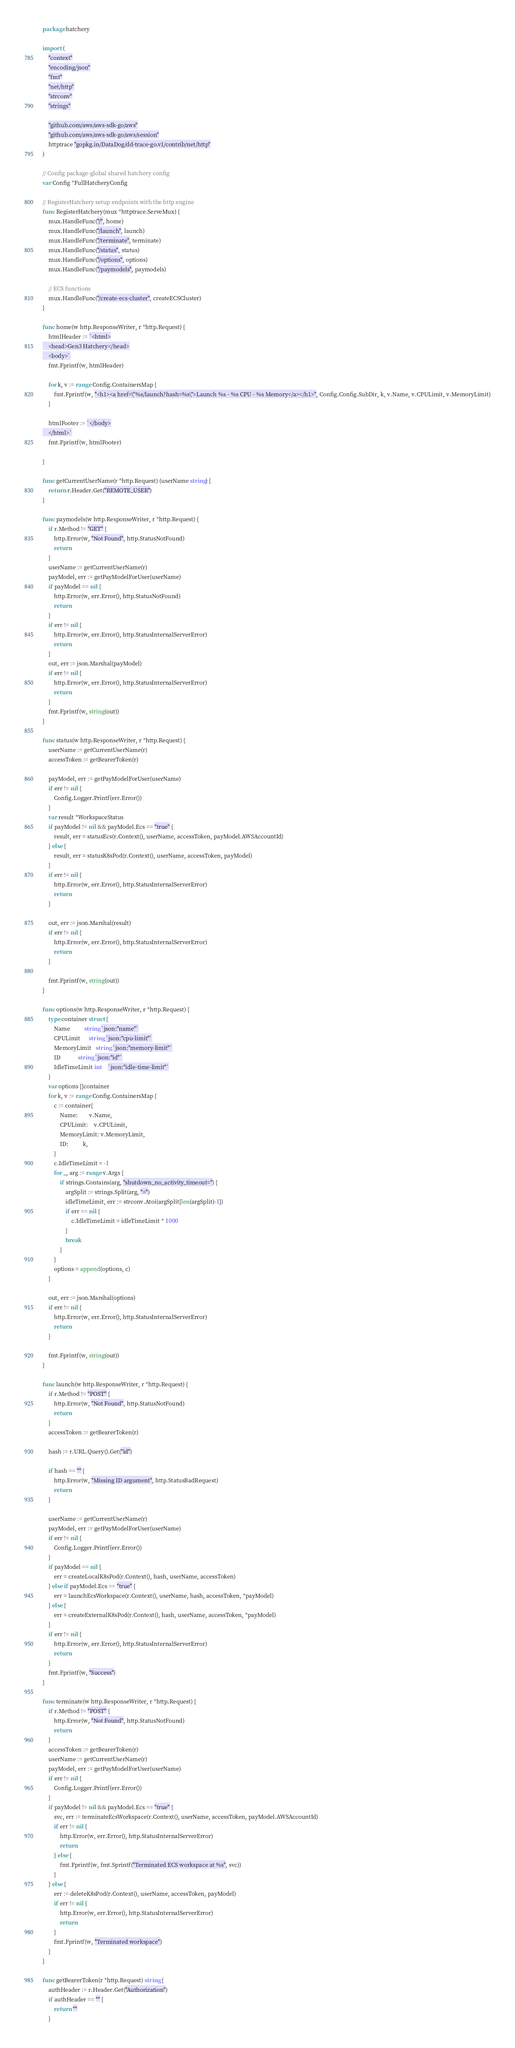<code> <loc_0><loc_0><loc_500><loc_500><_Go_>package hatchery

import (
	"context"
	"encoding/json"
	"fmt"
	"net/http"
	"strconv"
	"strings"

	"github.com/aws/aws-sdk-go/aws"
	"github.com/aws/aws-sdk-go/aws/session"
	httptrace "gopkg.in/DataDog/dd-trace-go.v1/contrib/net/http"
)

// Config package-global shared hatchery config
var Config *FullHatcheryConfig

// RegisterHatchery setup endpoints with the http engine
func RegisterHatchery(mux *httptrace.ServeMux) {
	mux.HandleFunc("/", home)
	mux.HandleFunc("/launch", launch)
	mux.HandleFunc("/terminate", terminate)
	mux.HandleFunc("/status", status)
	mux.HandleFunc("/options", options)
	mux.HandleFunc("/paymodels", paymodels)

	// ECS functions
	mux.HandleFunc("/create-ecs-cluster", createECSCluster)
}

func home(w http.ResponseWriter, r *http.Request) {
	htmlHeader := `<html>
	<head>Gen3 Hatchery</head>
	<body>`
	fmt.Fprintf(w, htmlHeader)

	for k, v := range Config.ContainersMap {
		fmt.Fprintf(w, "<h1><a href=\"%s/launch?hash=%s\">Launch %s - %s CPU - %s Memory</a></h1>", Config.Config.SubDir, k, v.Name, v.CPULimit, v.MemoryLimit)
	}

	htmlFooter := `</body>
	</html>`
	fmt.Fprintf(w, htmlFooter)

}

func getCurrentUserName(r *http.Request) (userName string) {
	return r.Header.Get("REMOTE_USER")
}

func paymodels(w http.ResponseWriter, r *http.Request) {
	if r.Method != "GET" {
		http.Error(w, "Not Found", http.StatusNotFound)
		return
	}
	userName := getCurrentUserName(r)
	payModel, err := getPayModelForUser(userName)
	if payModel == nil {
		http.Error(w, err.Error(), http.StatusNotFound)
		return
	}
	if err != nil {
		http.Error(w, err.Error(), http.StatusInternalServerError)
		return
	}
	out, err := json.Marshal(payModel)
	if err != nil {
		http.Error(w, err.Error(), http.StatusInternalServerError)
		return
	}
	fmt.Fprintf(w, string(out))
}

func status(w http.ResponseWriter, r *http.Request) {
	userName := getCurrentUserName(r)
	accessToken := getBearerToken(r)

	payModel, err := getPayModelForUser(userName)
	if err != nil {
		Config.Logger.Printf(err.Error())
	}
	var result *WorkspaceStatus
	if payModel != nil && payModel.Ecs == "true" {
		result, err = statusEcs(r.Context(), userName, accessToken, payModel.AWSAccountId)
	} else {
		result, err = statusK8sPod(r.Context(), userName, accessToken, payModel)
	}
	if err != nil {
		http.Error(w, err.Error(), http.StatusInternalServerError)
		return
	}

	out, err := json.Marshal(result)
	if err != nil {
		http.Error(w, err.Error(), http.StatusInternalServerError)
		return
	}

	fmt.Fprintf(w, string(out))
}

func options(w http.ResponseWriter, r *http.Request) {
	type container struct {
		Name          string `json:"name"`
		CPULimit      string `json:"cpu-limit"`
		MemoryLimit   string `json:"memory-limit"`
		ID            string `json:"id"`
		IdleTimeLimit int    `json:"idle-time-limit"`
	}
	var options []container
	for k, v := range Config.ContainersMap {
		c := container{
			Name:        v.Name,
			CPULimit:    v.CPULimit,
			MemoryLimit: v.MemoryLimit,
			ID:          k,
		}
		c.IdleTimeLimit = -1
		for _, arg := range v.Args {
			if strings.Contains(arg, "shutdown_no_activity_timeout=") {
				argSplit := strings.Split(arg, "=")
				idleTimeLimit, err := strconv.Atoi(argSplit[len(argSplit)-1])
				if err == nil {
					c.IdleTimeLimit = idleTimeLimit * 1000
				}
				break
			}
		}
		options = append(options, c)
	}

	out, err := json.Marshal(options)
	if err != nil {
		http.Error(w, err.Error(), http.StatusInternalServerError)
		return
	}

	fmt.Fprintf(w, string(out))
}

func launch(w http.ResponseWriter, r *http.Request) {
	if r.Method != "POST" {
		http.Error(w, "Not Found", http.StatusNotFound)
		return
	}
	accessToken := getBearerToken(r)

	hash := r.URL.Query().Get("id")

	if hash == "" {
		http.Error(w, "Missing ID argument", http.StatusBadRequest)
		return
	}

	userName := getCurrentUserName(r)
	payModel, err := getPayModelForUser(userName)
	if err != nil {
		Config.Logger.Printf(err.Error())
	}
	if payModel == nil {
		err = createLocalK8sPod(r.Context(), hash, userName, accessToken)
	} else if payModel.Ecs == "true" {
		err = launchEcsWorkspace(r.Context(), userName, hash, accessToken, *payModel)
	} else {
		err = createExternalK8sPod(r.Context(), hash, userName, accessToken, *payModel)
	}
	if err != nil {
		http.Error(w, err.Error(), http.StatusInternalServerError)
		return
	}
	fmt.Fprintf(w, "Success")
}

func terminate(w http.ResponseWriter, r *http.Request) {
	if r.Method != "POST" {
		http.Error(w, "Not Found", http.StatusNotFound)
		return
	}
	accessToken := getBearerToken(r)
	userName := getCurrentUserName(r)
	payModel, err := getPayModelForUser(userName)
	if err != nil {
		Config.Logger.Printf(err.Error())
	}
	if payModel != nil && payModel.Ecs == "true" {
		svc, err := terminateEcsWorkspace(r.Context(), userName, accessToken, payModel.AWSAccountId)
		if err != nil {
			http.Error(w, err.Error(), http.StatusInternalServerError)
			return
		} else {
			fmt.Fprintf(w, fmt.Sprintf("Terminated ECS workspace at %s", svc))
		}
	} else {
		err := deleteK8sPod(r.Context(), userName, accessToken, payModel)
		if err != nil {
			http.Error(w, err.Error(), http.StatusInternalServerError)
			return
		}
		fmt.Fprintf(w, "Terminated workspace")
	}
}

func getBearerToken(r *http.Request) string {
	authHeader := r.Header.Get("Authorization")
	if authHeader == "" {
		return ""
	}</code> 